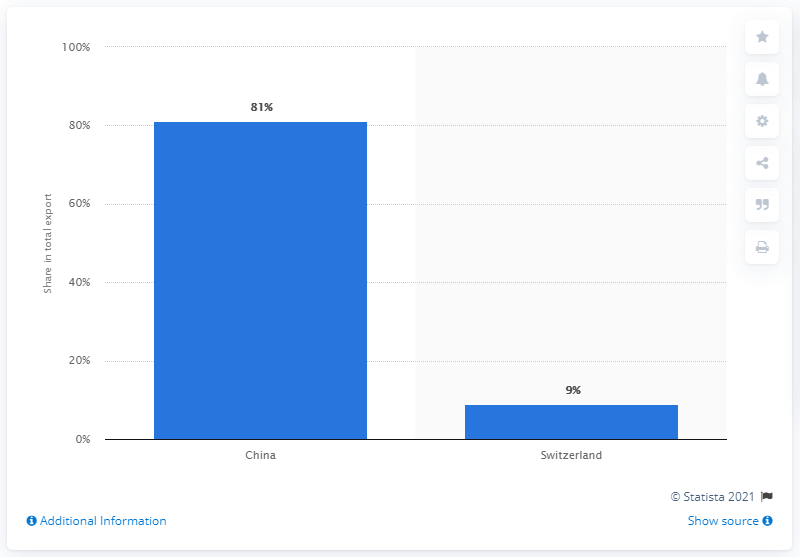What was the main export partner of Mongolia in 2019? In 2019, the main export partner of Mongolia was China, accounting for approximately 81% of Mongolia's total exports. This significant share underscores China's importance to Mongolia's trade and economy, highlighting the strong trade relations between the two neighboring countries. 